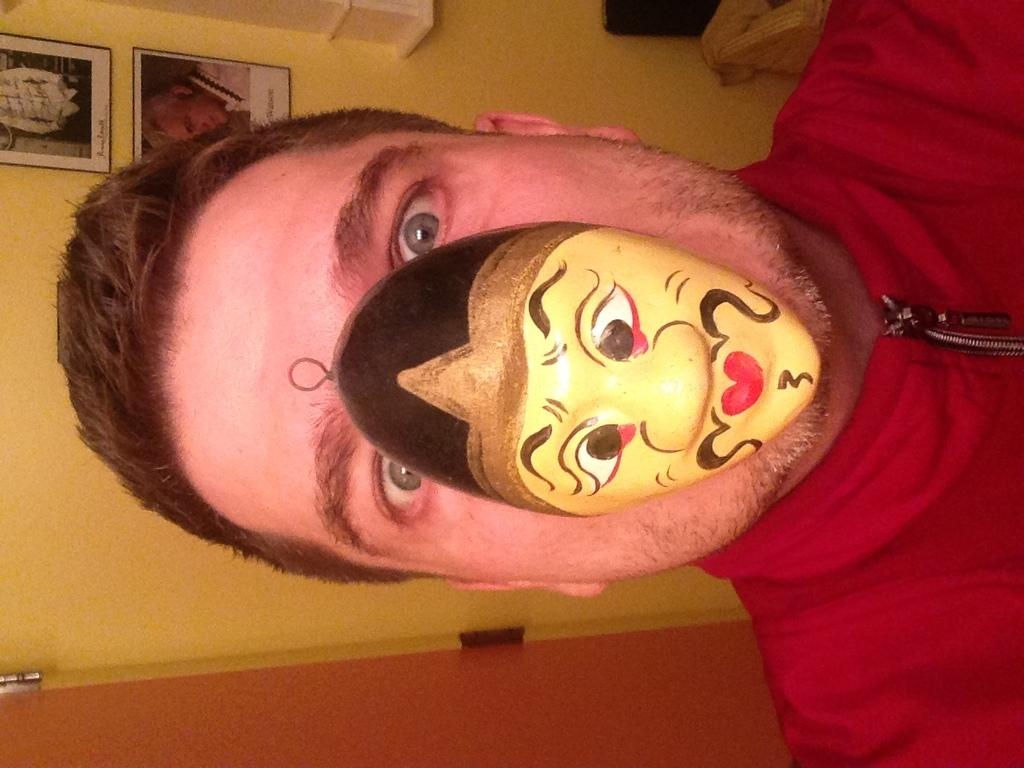What is the main subject of the image? There is a person in the image. Can you describe the person's attire? The person is wearing a red dress. What is the person wearing on their face? The person is wearing a mask on their face. What can be seen in the background of the image? There are frames attached to a cream-colored wall in the background. Is there any architectural feature visible in the image? Yes, there is a door visible in the image. How many cattle are grazing in the background of the image? There are no cattle present in the image; it features a person wearing a mask and a red dress, with frames on a cream-colored wall in the background. 